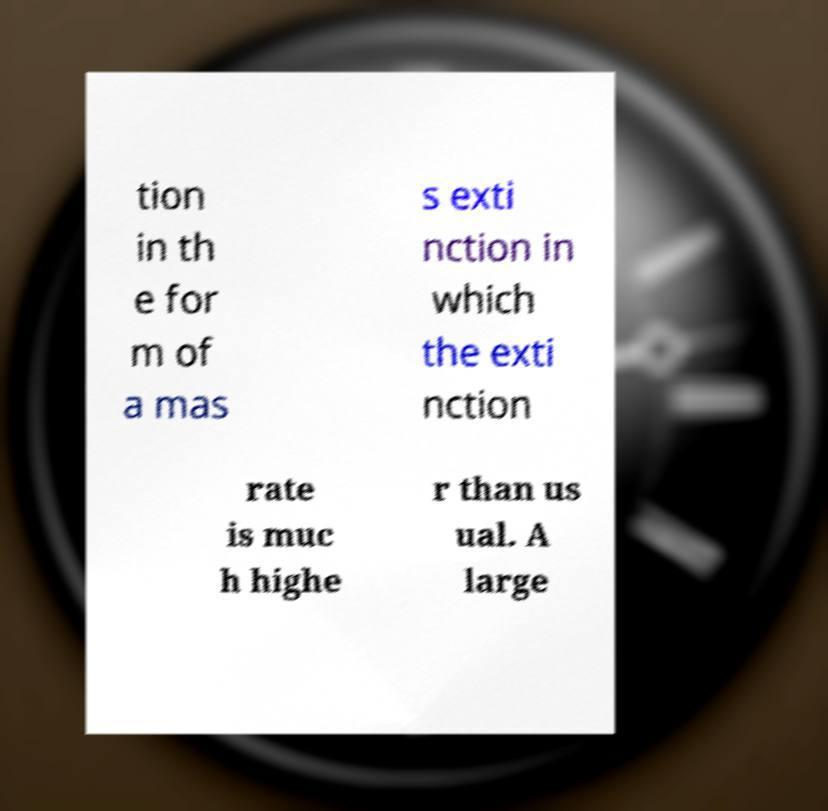Please identify and transcribe the text found in this image. tion in th e for m of a mas s exti nction in which the exti nction rate is muc h highe r than us ual. A large 